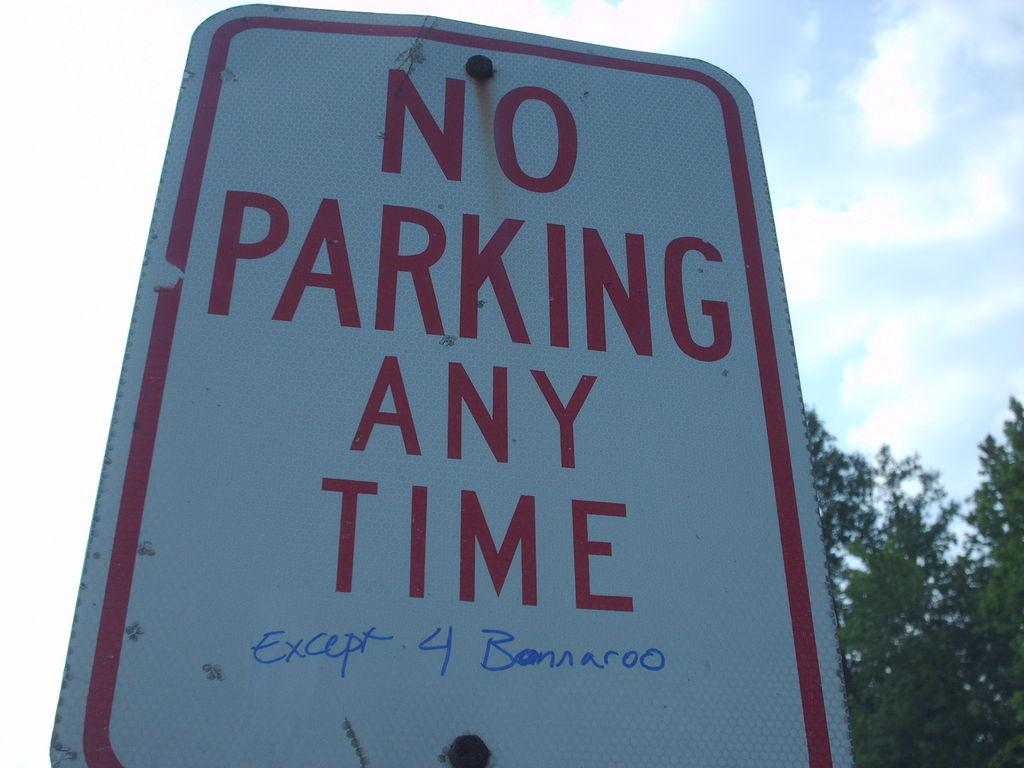<image>
Relay a brief, clear account of the picture shown. Someone scribble an exception to a "no parking" sign. 